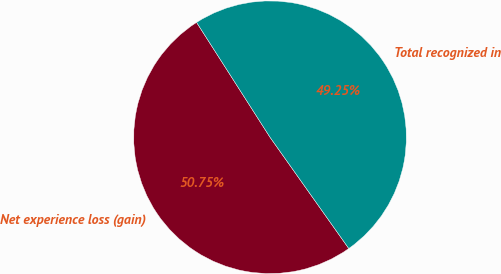Convert chart to OTSL. <chart><loc_0><loc_0><loc_500><loc_500><pie_chart><fcel>Net experience loss (gain)<fcel>Total recognized in<nl><fcel>50.75%<fcel>49.25%<nl></chart> 